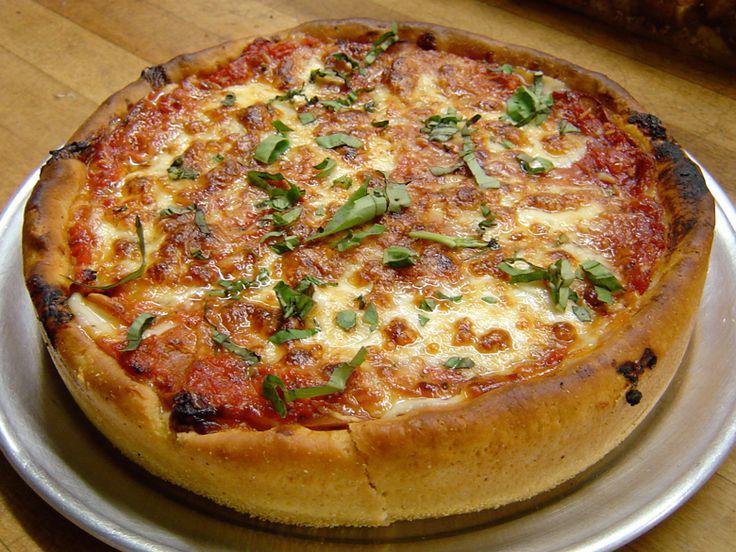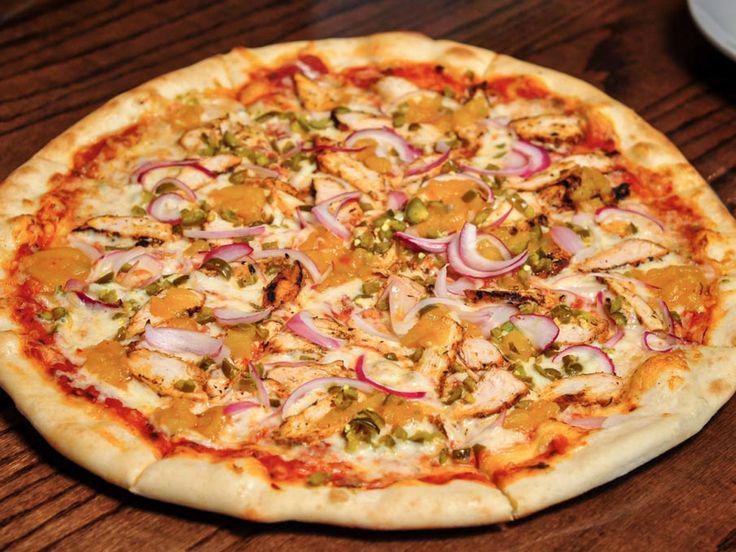The first image is the image on the left, the second image is the image on the right. Analyze the images presented: Is the assertion "There are two pizza that are perfect circles." valid? Answer yes or no. Yes. The first image is the image on the left, the second image is the image on the right. Examine the images to the left and right. Is the description "The left pizza has something green on it." accurate? Answer yes or no. Yes. 